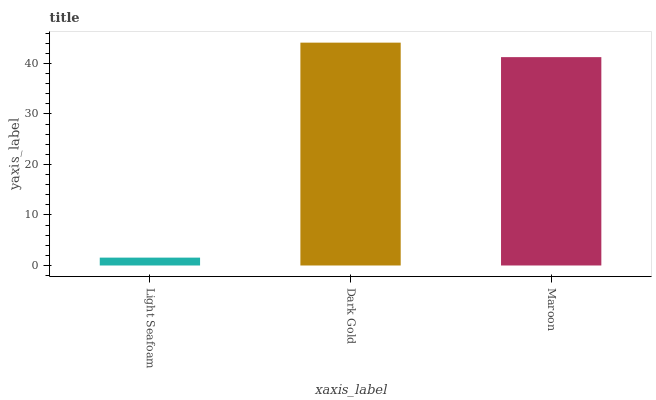Is Light Seafoam the minimum?
Answer yes or no. Yes. Is Dark Gold the maximum?
Answer yes or no. Yes. Is Maroon the minimum?
Answer yes or no. No. Is Maroon the maximum?
Answer yes or no. No. Is Dark Gold greater than Maroon?
Answer yes or no. Yes. Is Maroon less than Dark Gold?
Answer yes or no. Yes. Is Maroon greater than Dark Gold?
Answer yes or no. No. Is Dark Gold less than Maroon?
Answer yes or no. No. Is Maroon the high median?
Answer yes or no. Yes. Is Maroon the low median?
Answer yes or no. Yes. Is Dark Gold the high median?
Answer yes or no. No. Is Dark Gold the low median?
Answer yes or no. No. 